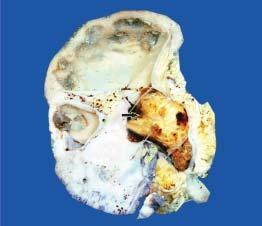what contains a single, large, soft yellow white stone taking the contour of the pelvi-calyceal system?
Answer the question using a single word or phrase. Pelvis of the kidney 